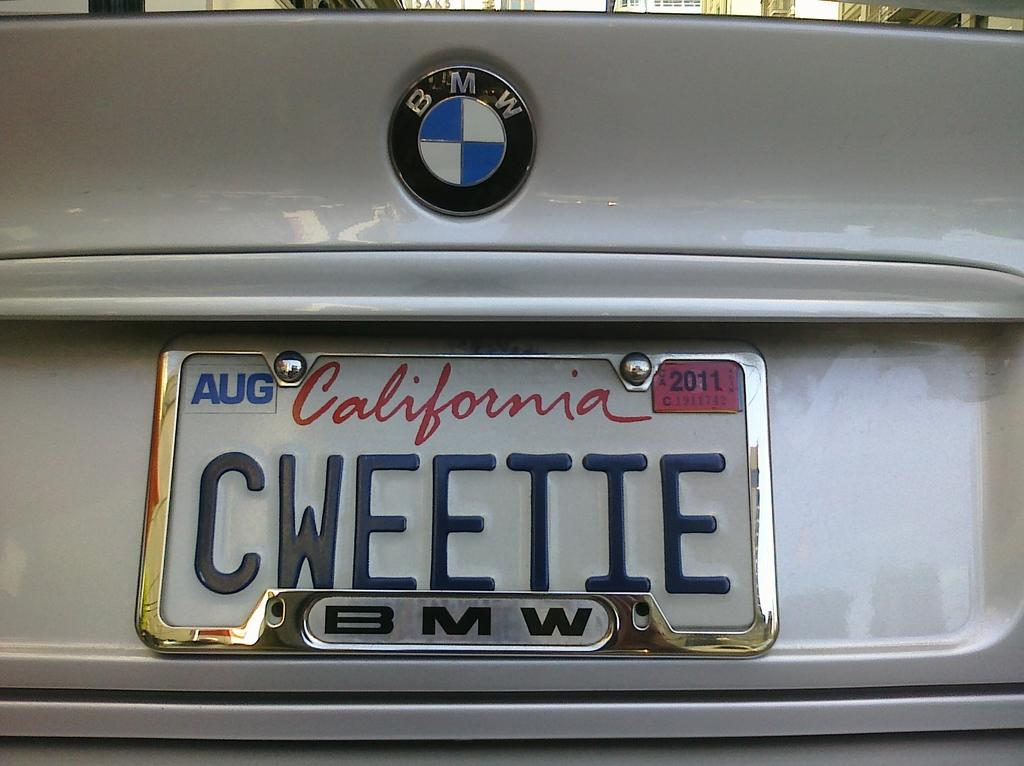<image>
Create a compact narrative representing the image presented. California license plate CWEETIE on a white BMW. 